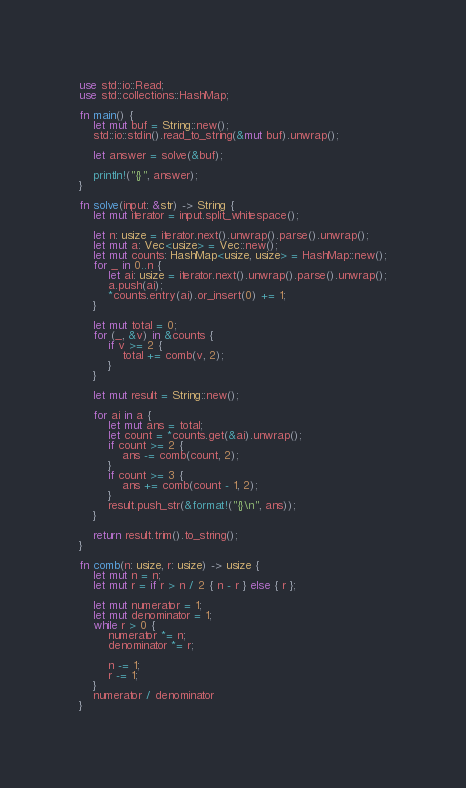Convert code to text. <code><loc_0><loc_0><loc_500><loc_500><_Rust_>use std::io::Read;
use std::collections::HashMap;

fn main() {
    let mut buf = String::new();
    std::io::stdin().read_to_string(&mut buf).unwrap();

    let answer = solve(&buf);

    println!("{}", answer);
}

fn solve(input: &str) -> String {
    let mut iterator = input.split_whitespace();

    let n: usize = iterator.next().unwrap().parse().unwrap();
    let mut a: Vec<usize> = Vec::new();
    let mut counts: HashMap<usize, usize> = HashMap::new();
    for _ in 0..n {
        let ai: usize = iterator.next().unwrap().parse().unwrap();
        a.push(ai);
        *counts.entry(ai).or_insert(0) += 1;
    }

    let mut total = 0;
    for (_, &v) in &counts {
        if v >= 2 {
            total += comb(v, 2);
        }
    }

    let mut result = String::new();

    for ai in a {
        let mut ans = total;
        let count = *counts.get(&ai).unwrap();
        if count >= 2 {
            ans -= comb(count, 2);
        }
        if count >= 3 {
            ans += comb(count - 1, 2);
        }
        result.push_str(&format!("{}\n", ans));
    }

    return result.trim().to_string();
}

fn comb(n: usize, r: usize) -> usize {
    let mut n = n;
    let mut r = if r > n / 2 { n - r } else { r };

    let mut numerator = 1;
    let mut denominator = 1;
    while r > 0 {
        numerator *= n;
        denominator *= r;

        n -= 1;
        r -= 1;
    }
    numerator / denominator
}
</code> 